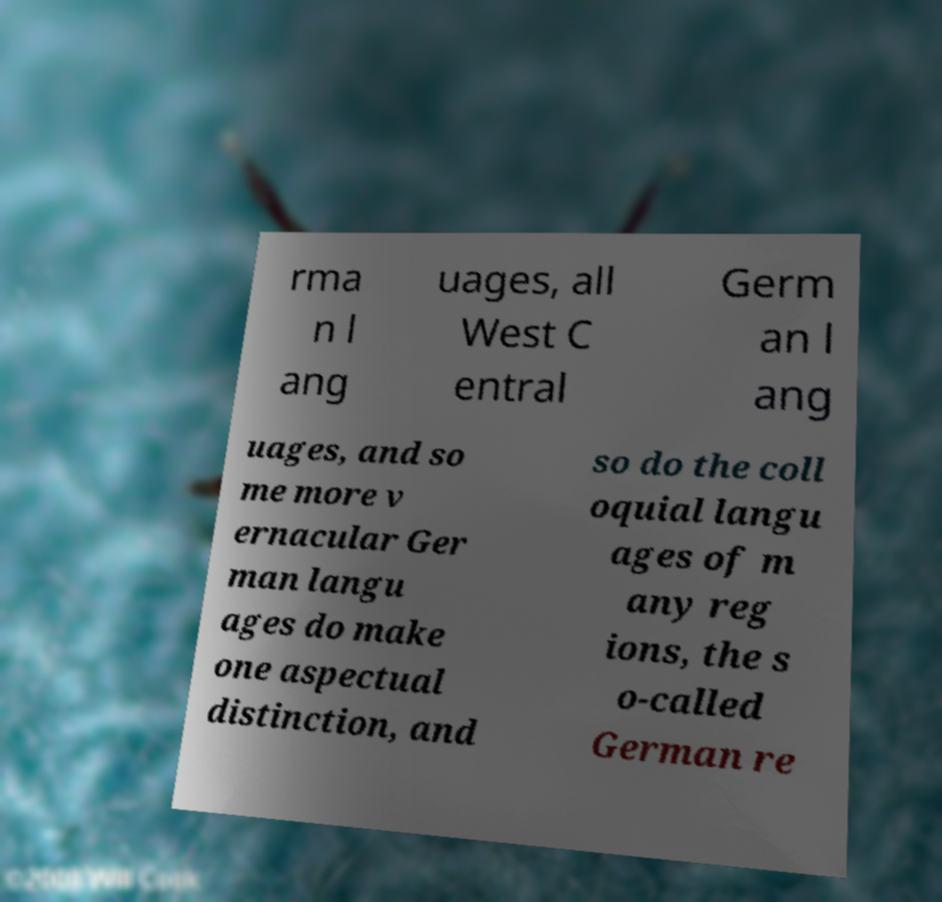What messages or text are displayed in this image? I need them in a readable, typed format. rma n l ang uages, all West C entral Germ an l ang uages, and so me more v ernacular Ger man langu ages do make one aspectual distinction, and so do the coll oquial langu ages of m any reg ions, the s o-called German re 